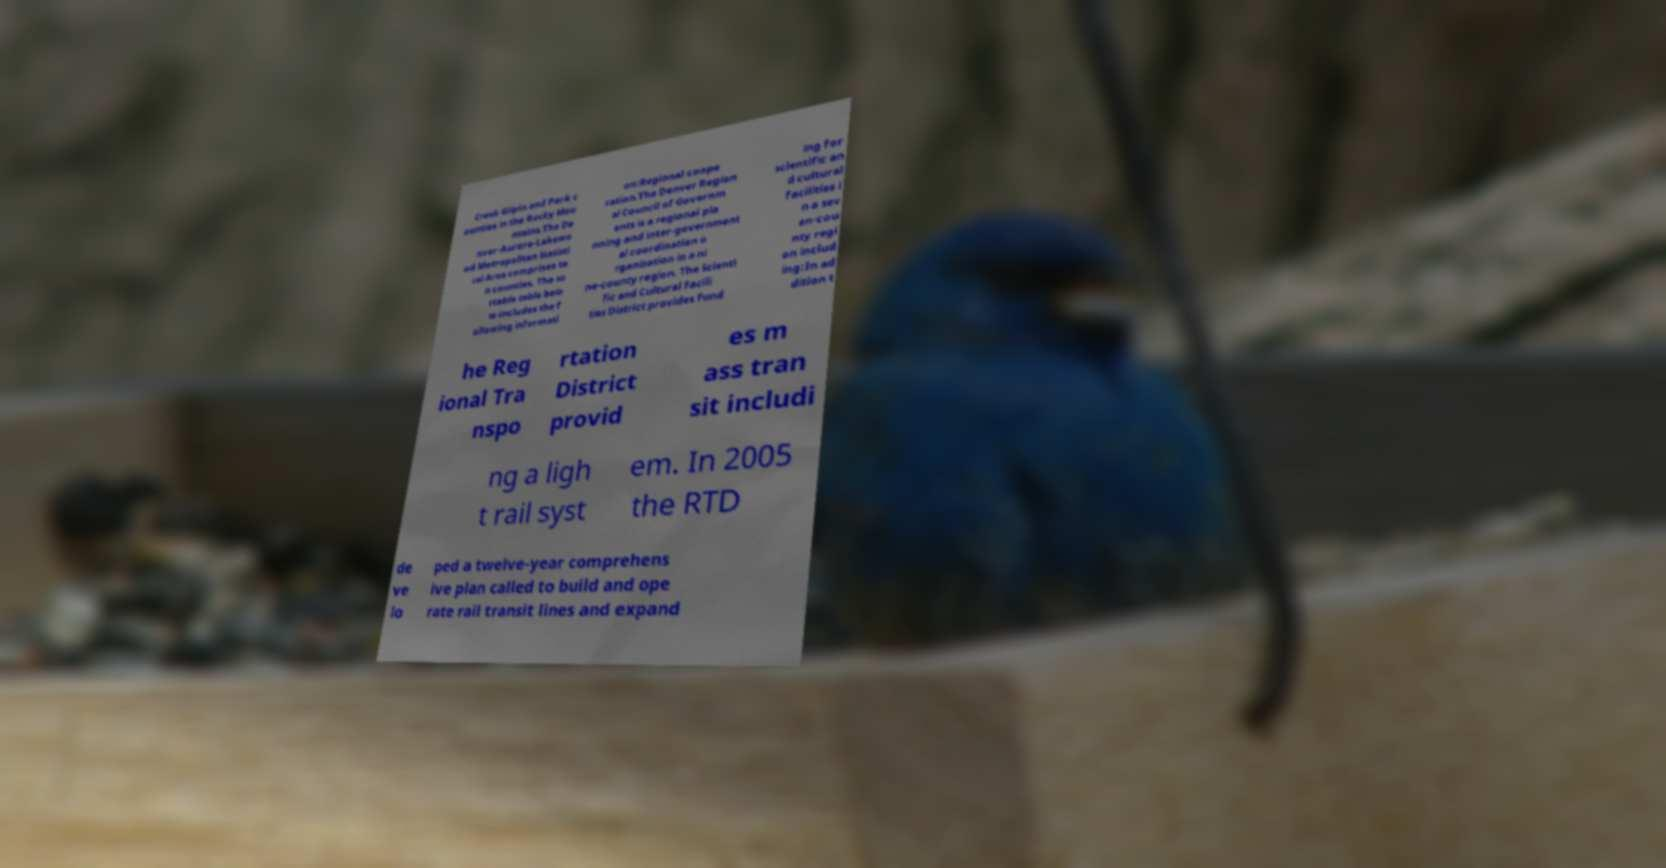Please identify and transcribe the text found in this image. Creek Gilpin and Park c ounties in the Rocky Mou ntains.The De nver-Aurora-Lakewo od Metropolitan Statisti cal Area comprises te n counties. The so rtable table belo w includes the f ollowing informati on:Regional coope ration.The Denver Region al Council of Governm ents is a regional pla nning and inter-government al coordination o rganization in a ni ne-county region. The Scienti fic and Cultural Facili ties District provides fund ing for scientific an d cultural facilities i n a sev en-cou nty regi on includ ing:In ad dition t he Reg ional Tra nspo rtation District provid es m ass tran sit includi ng a ligh t rail syst em. In 2005 the RTD de ve lo ped a twelve-year comprehens ive plan called to build and ope rate rail transit lines and expand 